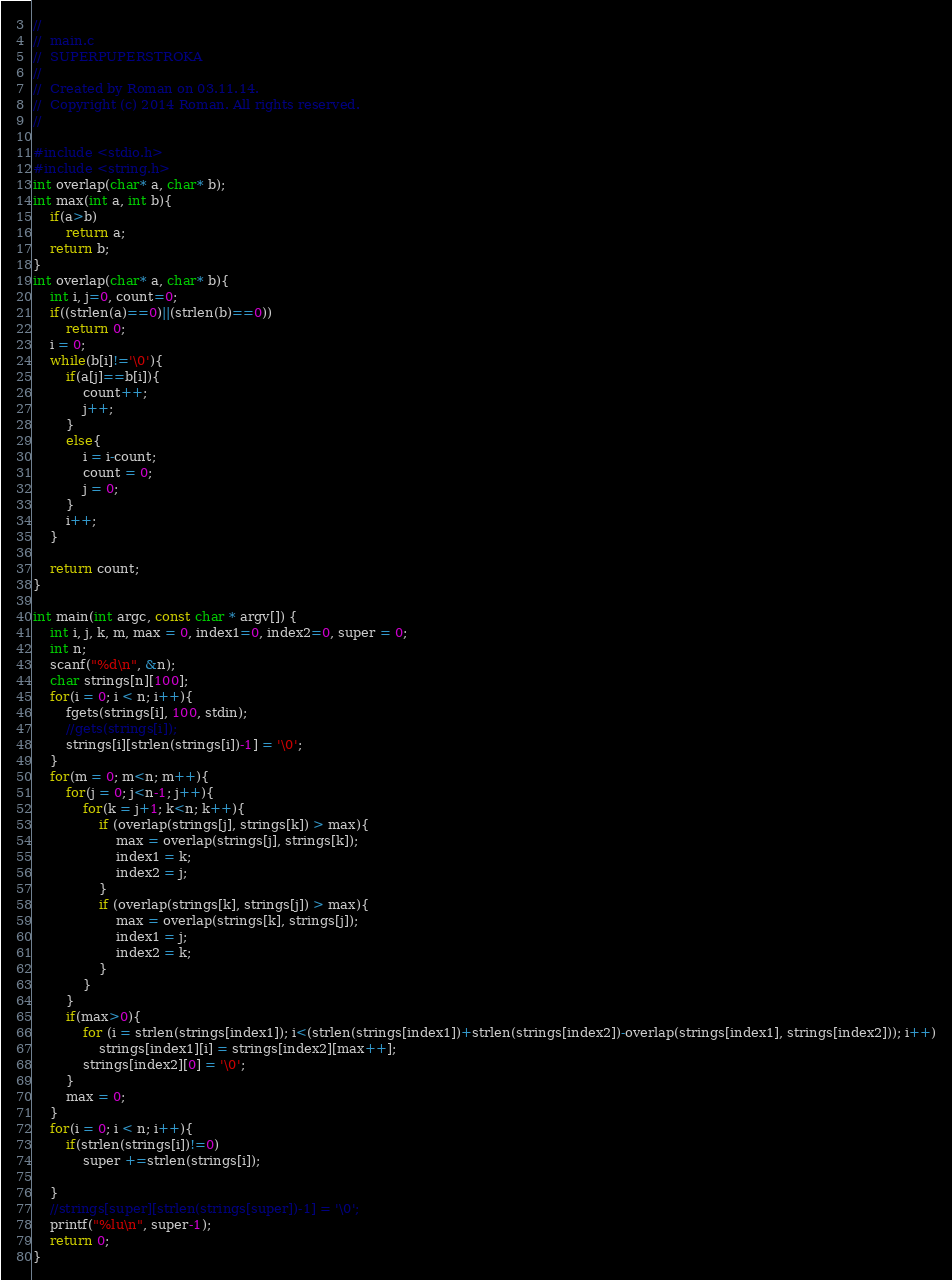Convert code to text. <code><loc_0><loc_0><loc_500><loc_500><_C_>//
//  main.c
//  SUPERPUPERSTROKA
//
//  Created by Roman on 03.11.14.
//  Copyright (c) 2014 Roman. All rights reserved.
//

#include <stdio.h>
#include <string.h>
int overlap(char* a, char* b);
int max(int a, int b){
    if(a>b)
        return a;
    return b;
}
int overlap(char* a, char* b){
    int i, j=0, count=0;
    if((strlen(a)==0)||(strlen(b)==0))
        return 0;
    i = 0;
    while(b[i]!='\0'){
        if(a[j]==b[i]){
            count++;
            j++;
        }
        else{
            i = i-count;
            count = 0;
            j = 0;
        }
        i++;
    }
    
    return count;
}

int main(int argc, const char * argv[]) {
    int i, j, k, m, max = 0, index1=0, index2=0, super = 0;
    int n;
    scanf("%d\n", &n);
    char strings[n][100];
    for(i = 0; i < n; i++){
        fgets(strings[i], 100, stdin);
        //gets(strings[i]);
        strings[i][strlen(strings[i])-1] = '\0';
    }
    for(m = 0; m<n; m++){
        for(j = 0; j<n-1; j++){
            for(k = j+1; k<n; k++){
                if (overlap(strings[j], strings[k]) > max){
                    max = overlap(strings[j], strings[k]);
                    index1 = k;
                    index2 = j;
                }
                if (overlap(strings[k], strings[j]) > max){
                    max = overlap(strings[k], strings[j]);
                    index1 = j;
                    index2 = k;
                }
            }
        }
        if(max>0){
            for (i = strlen(strings[index1]); i<(strlen(strings[index1])+strlen(strings[index2])-overlap(strings[index1], strings[index2])); i++)
                strings[index1][i] = strings[index2][max++];
            strings[index2][0] = '\0';
        }
        max = 0;
    }
    for(i = 0; i < n; i++){
        if(strlen(strings[i])!=0)
            super +=strlen(strings[i]);
            
    }
    //strings[super][strlen(strings[super])-1] = '\0';
    printf("%lu\n", super-1);
    return 0;
}
</code> 